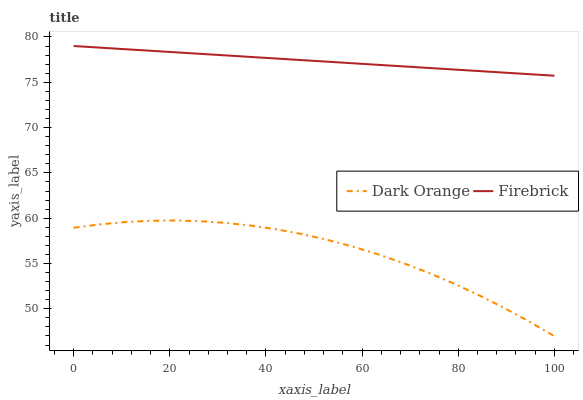Does Dark Orange have the minimum area under the curve?
Answer yes or no. Yes. Does Firebrick have the maximum area under the curve?
Answer yes or no. Yes. Does Firebrick have the minimum area under the curve?
Answer yes or no. No. Is Firebrick the smoothest?
Answer yes or no. Yes. Is Dark Orange the roughest?
Answer yes or no. Yes. Is Firebrick the roughest?
Answer yes or no. No. Does Dark Orange have the lowest value?
Answer yes or no. Yes. Does Firebrick have the lowest value?
Answer yes or no. No. Does Firebrick have the highest value?
Answer yes or no. Yes. Is Dark Orange less than Firebrick?
Answer yes or no. Yes. Is Firebrick greater than Dark Orange?
Answer yes or no. Yes. Does Dark Orange intersect Firebrick?
Answer yes or no. No. 